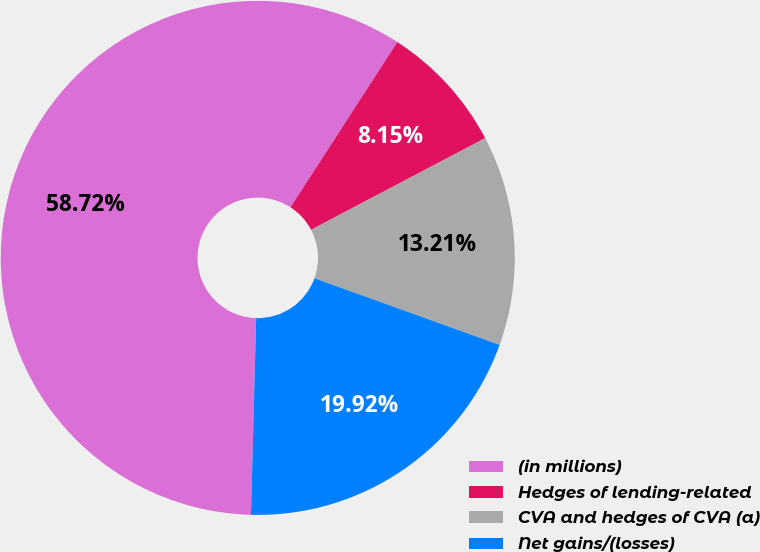Convert chart to OTSL. <chart><loc_0><loc_0><loc_500><loc_500><pie_chart><fcel>(in millions)<fcel>Hedges of lending-related<fcel>CVA and hedges of CVA (a)<fcel>Net gains/(losses)<nl><fcel>58.72%<fcel>8.15%<fcel>13.21%<fcel>19.92%<nl></chart> 